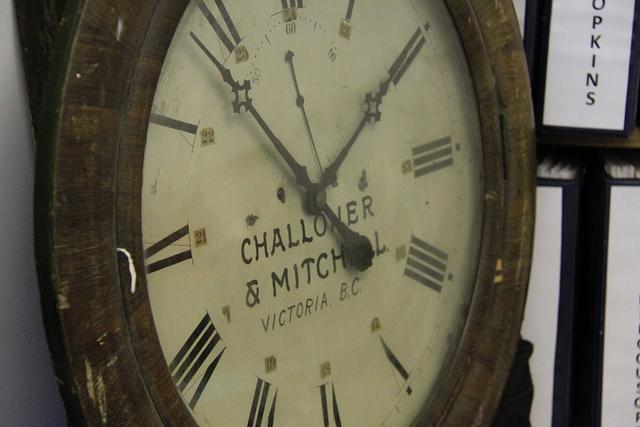What time does the clock say?
Concise answer only. 1:53. Does the clock work?
Write a very short answer. Yes. Do you see a word that starts with V?
Concise answer only. Yes. 